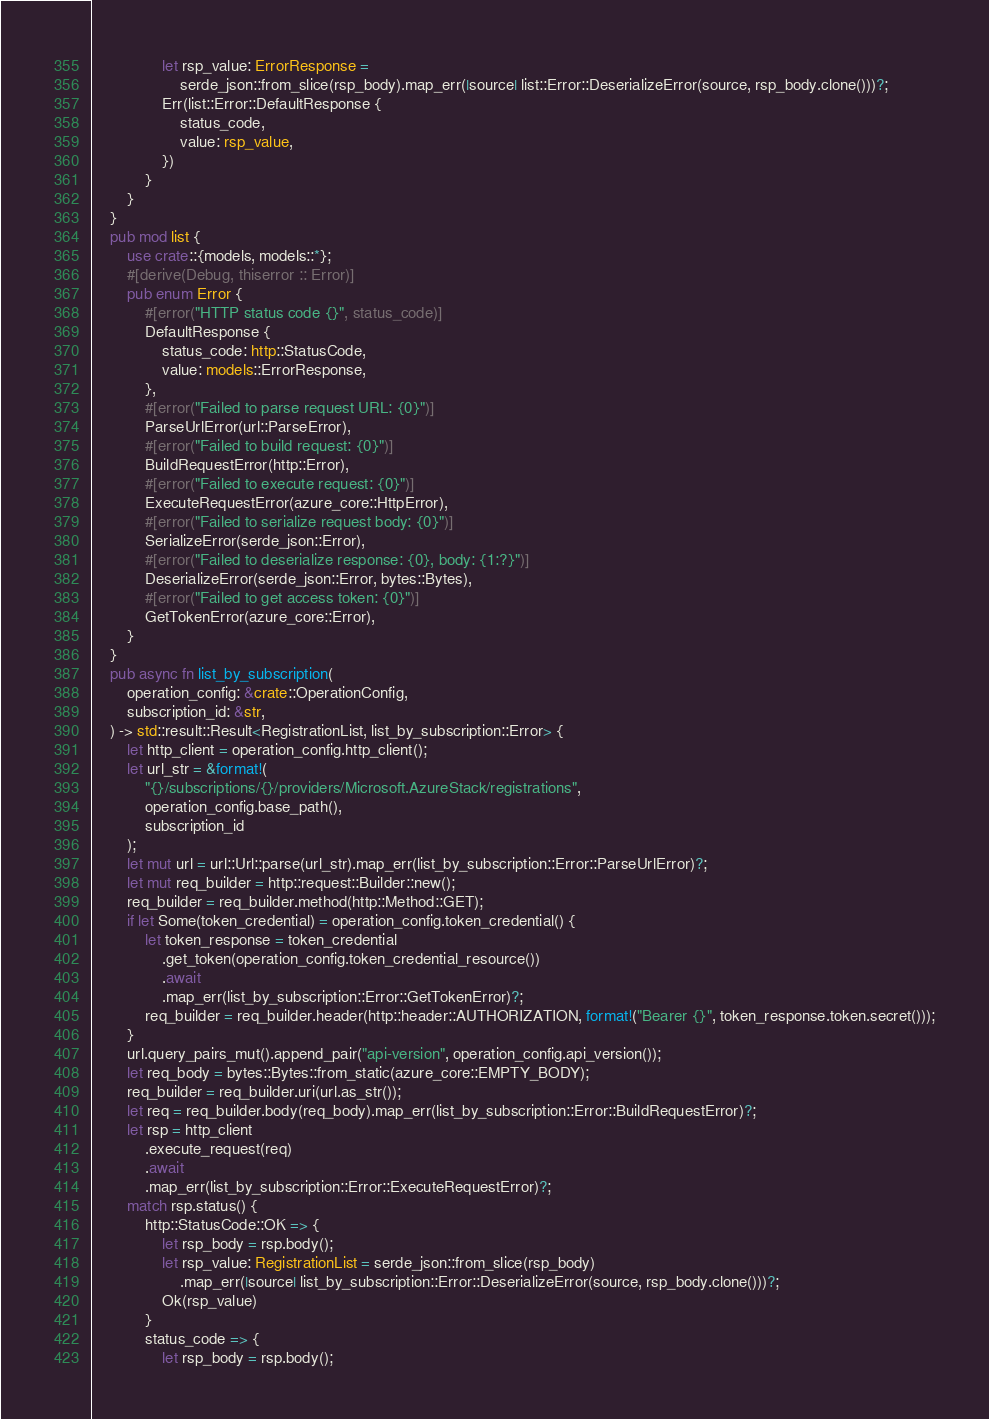Convert code to text. <code><loc_0><loc_0><loc_500><loc_500><_Rust_>                let rsp_value: ErrorResponse =
                    serde_json::from_slice(rsp_body).map_err(|source| list::Error::DeserializeError(source, rsp_body.clone()))?;
                Err(list::Error::DefaultResponse {
                    status_code,
                    value: rsp_value,
                })
            }
        }
    }
    pub mod list {
        use crate::{models, models::*};
        #[derive(Debug, thiserror :: Error)]
        pub enum Error {
            #[error("HTTP status code {}", status_code)]
            DefaultResponse {
                status_code: http::StatusCode,
                value: models::ErrorResponse,
            },
            #[error("Failed to parse request URL: {0}")]
            ParseUrlError(url::ParseError),
            #[error("Failed to build request: {0}")]
            BuildRequestError(http::Error),
            #[error("Failed to execute request: {0}")]
            ExecuteRequestError(azure_core::HttpError),
            #[error("Failed to serialize request body: {0}")]
            SerializeError(serde_json::Error),
            #[error("Failed to deserialize response: {0}, body: {1:?}")]
            DeserializeError(serde_json::Error, bytes::Bytes),
            #[error("Failed to get access token: {0}")]
            GetTokenError(azure_core::Error),
        }
    }
    pub async fn list_by_subscription(
        operation_config: &crate::OperationConfig,
        subscription_id: &str,
    ) -> std::result::Result<RegistrationList, list_by_subscription::Error> {
        let http_client = operation_config.http_client();
        let url_str = &format!(
            "{}/subscriptions/{}/providers/Microsoft.AzureStack/registrations",
            operation_config.base_path(),
            subscription_id
        );
        let mut url = url::Url::parse(url_str).map_err(list_by_subscription::Error::ParseUrlError)?;
        let mut req_builder = http::request::Builder::new();
        req_builder = req_builder.method(http::Method::GET);
        if let Some(token_credential) = operation_config.token_credential() {
            let token_response = token_credential
                .get_token(operation_config.token_credential_resource())
                .await
                .map_err(list_by_subscription::Error::GetTokenError)?;
            req_builder = req_builder.header(http::header::AUTHORIZATION, format!("Bearer {}", token_response.token.secret()));
        }
        url.query_pairs_mut().append_pair("api-version", operation_config.api_version());
        let req_body = bytes::Bytes::from_static(azure_core::EMPTY_BODY);
        req_builder = req_builder.uri(url.as_str());
        let req = req_builder.body(req_body).map_err(list_by_subscription::Error::BuildRequestError)?;
        let rsp = http_client
            .execute_request(req)
            .await
            .map_err(list_by_subscription::Error::ExecuteRequestError)?;
        match rsp.status() {
            http::StatusCode::OK => {
                let rsp_body = rsp.body();
                let rsp_value: RegistrationList = serde_json::from_slice(rsp_body)
                    .map_err(|source| list_by_subscription::Error::DeserializeError(source, rsp_body.clone()))?;
                Ok(rsp_value)
            }
            status_code => {
                let rsp_body = rsp.body();</code> 